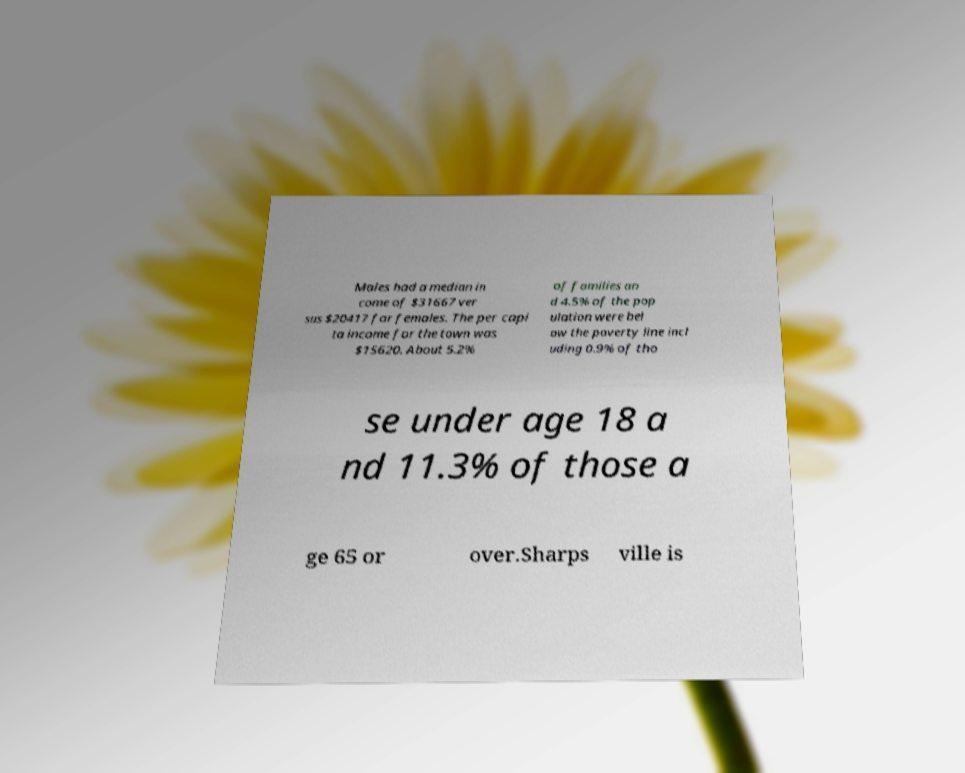Please read and relay the text visible in this image. What does it say? Males had a median in come of $31667 ver sus $20417 for females. The per capi ta income for the town was $15620. About 5.2% of families an d 4.5% of the pop ulation were bel ow the poverty line incl uding 0.9% of tho se under age 18 a nd 11.3% of those a ge 65 or over.Sharps ville is 